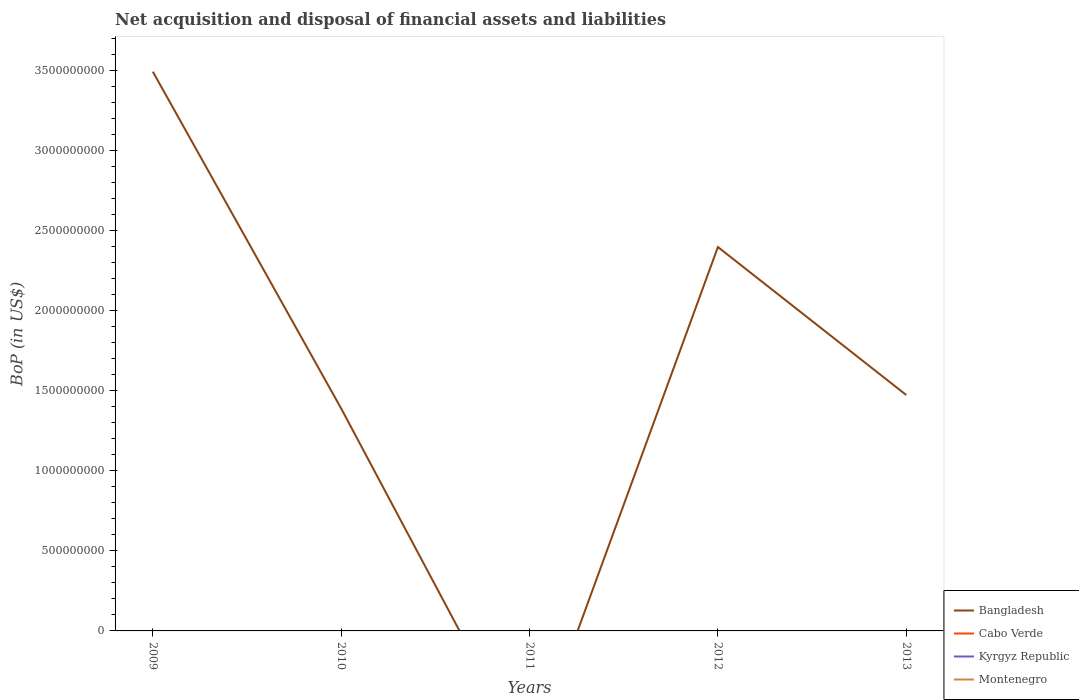What is the total Balance of Payments in Bangladesh in the graph?
Offer a very short reply. 2.10e+09. What is the difference between the highest and the second highest Balance of Payments in Bangladesh?
Give a very brief answer. 3.49e+09. Is the Balance of Payments in Bangladesh strictly greater than the Balance of Payments in Montenegro over the years?
Keep it short and to the point. No. What is the difference between two consecutive major ticks on the Y-axis?
Provide a short and direct response. 5.00e+08. Are the values on the major ticks of Y-axis written in scientific E-notation?
Make the answer very short. No. Does the graph contain grids?
Your answer should be very brief. No. Where does the legend appear in the graph?
Offer a terse response. Bottom right. How many legend labels are there?
Offer a very short reply. 4. How are the legend labels stacked?
Keep it short and to the point. Vertical. What is the title of the graph?
Keep it short and to the point. Net acquisition and disposal of financial assets and liabilities. What is the label or title of the X-axis?
Your answer should be very brief. Years. What is the label or title of the Y-axis?
Your response must be concise. BoP (in US$). What is the BoP (in US$) of Bangladesh in 2009?
Provide a succinct answer. 3.49e+09. What is the BoP (in US$) of Cabo Verde in 2009?
Make the answer very short. 0. What is the BoP (in US$) in Kyrgyz Republic in 2009?
Make the answer very short. 0. What is the BoP (in US$) of Bangladesh in 2010?
Keep it short and to the point. 1.39e+09. What is the BoP (in US$) of Kyrgyz Republic in 2010?
Make the answer very short. 0. What is the BoP (in US$) in Cabo Verde in 2011?
Your response must be concise. 0. What is the BoP (in US$) of Kyrgyz Republic in 2011?
Your answer should be very brief. 0. What is the BoP (in US$) in Montenegro in 2011?
Make the answer very short. 0. What is the BoP (in US$) of Bangladesh in 2012?
Provide a succinct answer. 2.40e+09. What is the BoP (in US$) of Cabo Verde in 2012?
Keep it short and to the point. 0. What is the BoP (in US$) in Kyrgyz Republic in 2012?
Provide a short and direct response. 0. What is the BoP (in US$) of Montenegro in 2012?
Your answer should be compact. 0. What is the BoP (in US$) in Bangladesh in 2013?
Offer a terse response. 1.47e+09. What is the BoP (in US$) in Cabo Verde in 2013?
Provide a succinct answer. 0. What is the BoP (in US$) of Montenegro in 2013?
Make the answer very short. 0. Across all years, what is the maximum BoP (in US$) of Bangladesh?
Your answer should be compact. 3.49e+09. What is the total BoP (in US$) of Bangladesh in the graph?
Provide a short and direct response. 8.75e+09. What is the total BoP (in US$) of Kyrgyz Republic in the graph?
Provide a short and direct response. 0. What is the total BoP (in US$) of Montenegro in the graph?
Keep it short and to the point. 0. What is the difference between the BoP (in US$) in Bangladesh in 2009 and that in 2010?
Your answer should be compact. 2.10e+09. What is the difference between the BoP (in US$) in Bangladesh in 2009 and that in 2012?
Provide a succinct answer. 1.09e+09. What is the difference between the BoP (in US$) of Bangladesh in 2009 and that in 2013?
Make the answer very short. 2.02e+09. What is the difference between the BoP (in US$) in Bangladesh in 2010 and that in 2012?
Provide a short and direct response. -1.01e+09. What is the difference between the BoP (in US$) in Bangladesh in 2010 and that in 2013?
Your response must be concise. -8.44e+07. What is the difference between the BoP (in US$) of Bangladesh in 2012 and that in 2013?
Your response must be concise. 9.24e+08. What is the average BoP (in US$) in Bangladesh per year?
Make the answer very short. 1.75e+09. What is the ratio of the BoP (in US$) in Bangladesh in 2009 to that in 2010?
Keep it short and to the point. 2.51. What is the ratio of the BoP (in US$) of Bangladesh in 2009 to that in 2012?
Keep it short and to the point. 1.46. What is the ratio of the BoP (in US$) in Bangladesh in 2009 to that in 2013?
Provide a short and direct response. 2.37. What is the ratio of the BoP (in US$) in Bangladesh in 2010 to that in 2012?
Provide a succinct answer. 0.58. What is the ratio of the BoP (in US$) in Bangladesh in 2010 to that in 2013?
Your response must be concise. 0.94. What is the ratio of the BoP (in US$) in Bangladesh in 2012 to that in 2013?
Give a very brief answer. 1.63. What is the difference between the highest and the second highest BoP (in US$) of Bangladesh?
Keep it short and to the point. 1.09e+09. What is the difference between the highest and the lowest BoP (in US$) of Bangladesh?
Give a very brief answer. 3.49e+09. 